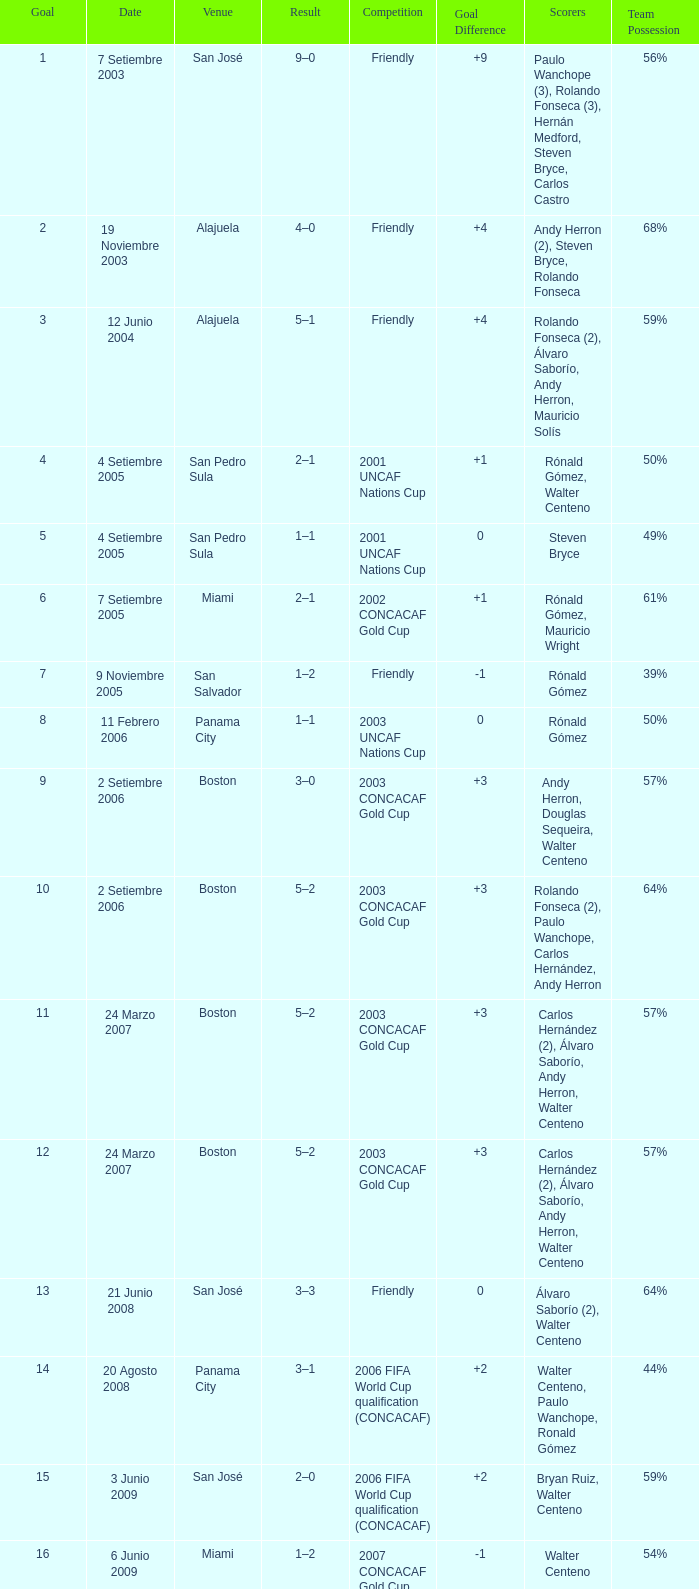At the venue of panama city, on 11 Febrero 2006, how many goals were scored? 1.0. 